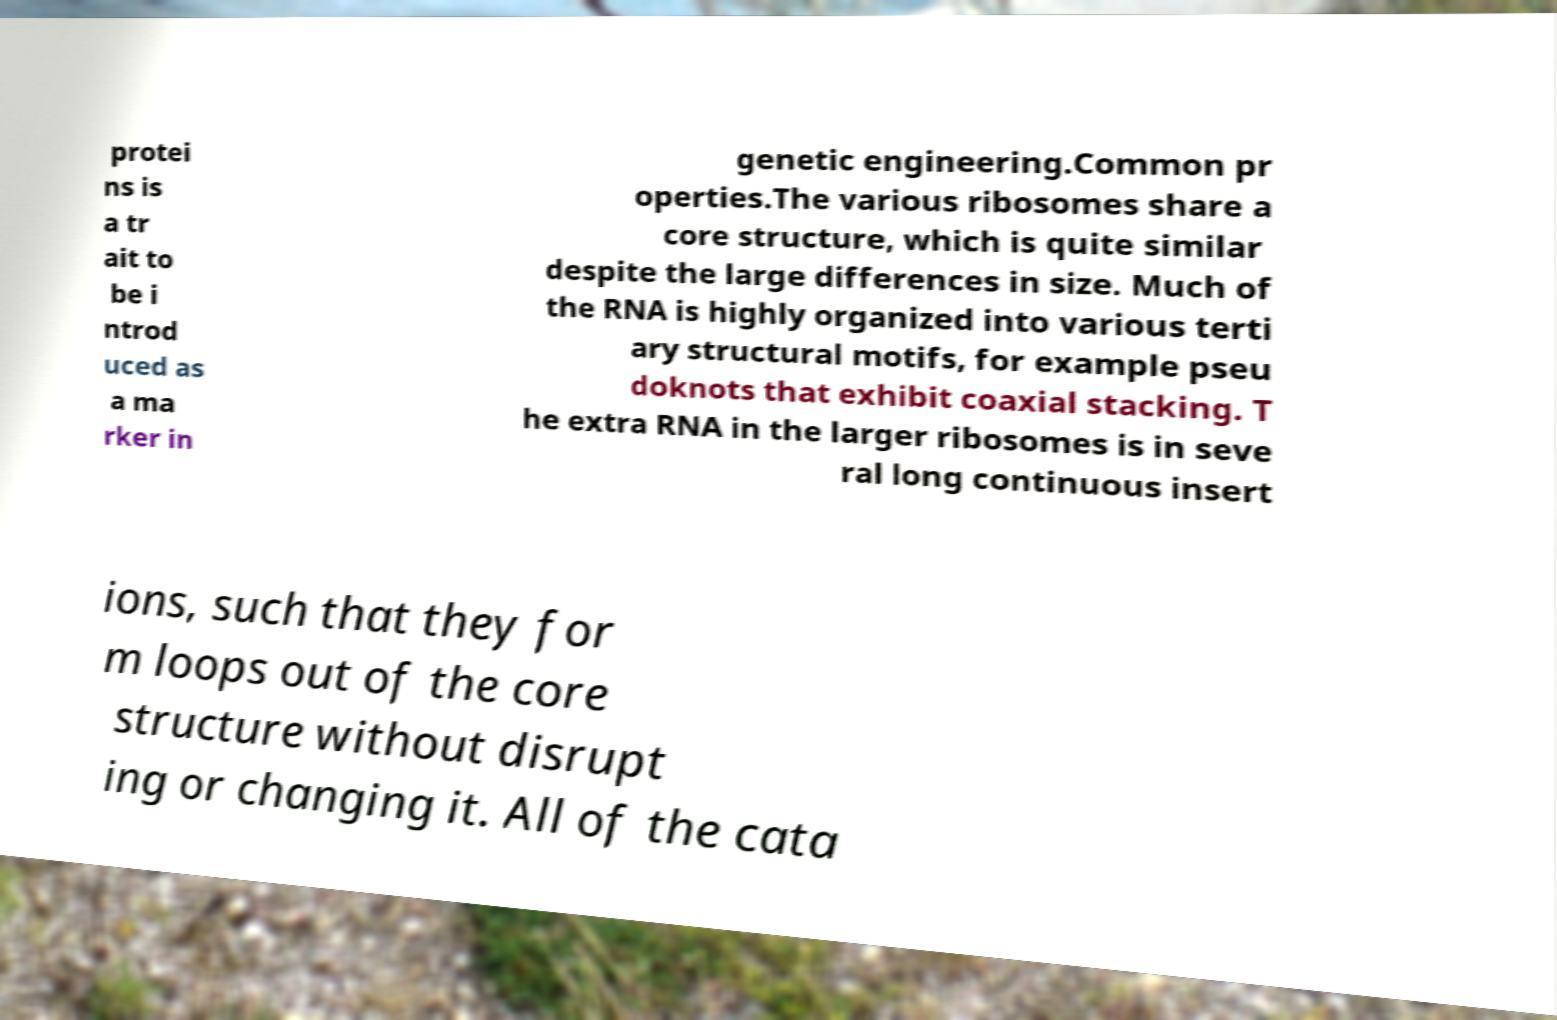For documentation purposes, I need the text within this image transcribed. Could you provide that? protei ns is a tr ait to be i ntrod uced as a ma rker in genetic engineering.Common pr operties.The various ribosomes share a core structure, which is quite similar despite the large differences in size. Much of the RNA is highly organized into various terti ary structural motifs, for example pseu doknots that exhibit coaxial stacking. T he extra RNA in the larger ribosomes is in seve ral long continuous insert ions, such that they for m loops out of the core structure without disrupt ing or changing it. All of the cata 